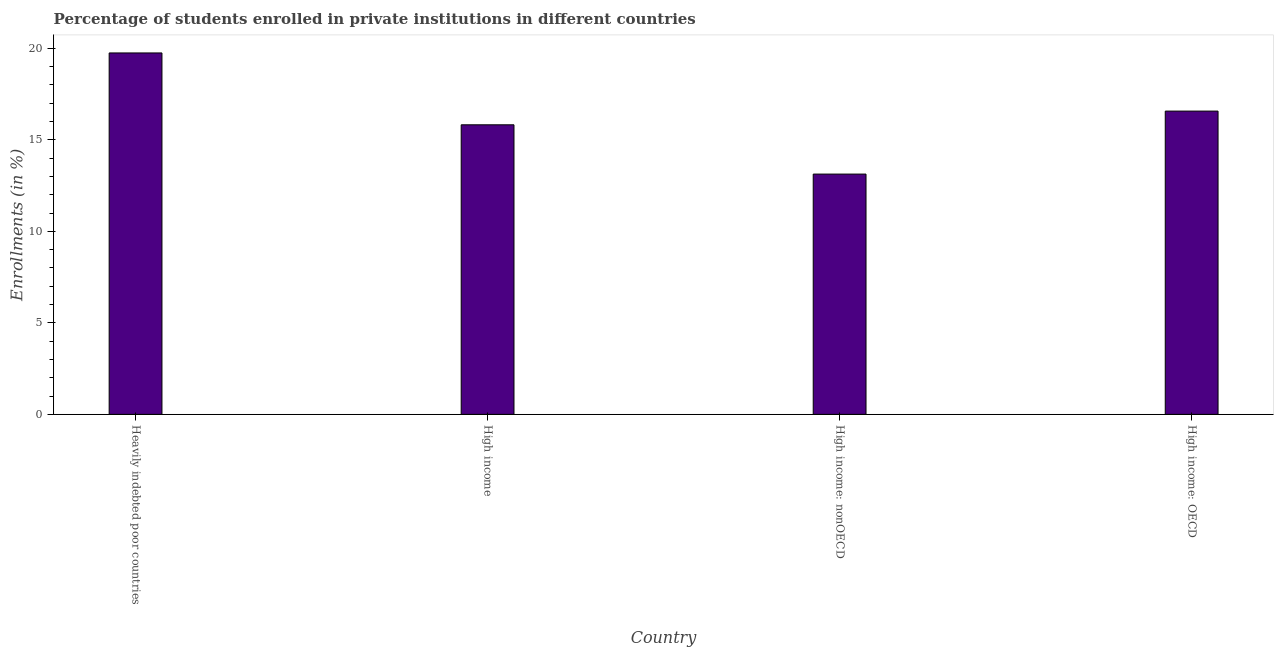Does the graph contain any zero values?
Your response must be concise. No. What is the title of the graph?
Ensure brevity in your answer.  Percentage of students enrolled in private institutions in different countries. What is the label or title of the X-axis?
Your answer should be very brief. Country. What is the label or title of the Y-axis?
Provide a short and direct response. Enrollments (in %). What is the enrollments in private institutions in High income: nonOECD?
Your response must be concise. 13.13. Across all countries, what is the maximum enrollments in private institutions?
Offer a very short reply. 19.75. Across all countries, what is the minimum enrollments in private institutions?
Keep it short and to the point. 13.13. In which country was the enrollments in private institutions maximum?
Your response must be concise. Heavily indebted poor countries. In which country was the enrollments in private institutions minimum?
Make the answer very short. High income: nonOECD. What is the sum of the enrollments in private institutions?
Give a very brief answer. 65.26. What is the difference between the enrollments in private institutions in Heavily indebted poor countries and High income: nonOECD?
Offer a very short reply. 6.62. What is the average enrollments in private institutions per country?
Offer a very short reply. 16.32. What is the median enrollments in private institutions?
Offer a very short reply. 16.2. In how many countries, is the enrollments in private institutions greater than 11 %?
Offer a very short reply. 4. What is the ratio of the enrollments in private institutions in Heavily indebted poor countries to that in High income: OECD?
Give a very brief answer. 1.19. Is the enrollments in private institutions in High income less than that in High income: OECD?
Provide a succinct answer. Yes. What is the difference between the highest and the second highest enrollments in private institutions?
Give a very brief answer. 3.18. What is the difference between the highest and the lowest enrollments in private institutions?
Ensure brevity in your answer.  6.62. In how many countries, is the enrollments in private institutions greater than the average enrollments in private institutions taken over all countries?
Make the answer very short. 2. What is the Enrollments (in %) of Heavily indebted poor countries?
Your answer should be compact. 19.75. What is the Enrollments (in %) of High income?
Your response must be concise. 15.82. What is the Enrollments (in %) in High income: nonOECD?
Give a very brief answer. 13.13. What is the Enrollments (in %) in High income: OECD?
Give a very brief answer. 16.57. What is the difference between the Enrollments (in %) in Heavily indebted poor countries and High income?
Provide a short and direct response. 3.93. What is the difference between the Enrollments (in %) in Heavily indebted poor countries and High income: nonOECD?
Offer a terse response. 6.62. What is the difference between the Enrollments (in %) in Heavily indebted poor countries and High income: OECD?
Your response must be concise. 3.18. What is the difference between the Enrollments (in %) in High income and High income: nonOECD?
Provide a succinct answer. 2.69. What is the difference between the Enrollments (in %) in High income and High income: OECD?
Give a very brief answer. -0.75. What is the difference between the Enrollments (in %) in High income: nonOECD and High income: OECD?
Keep it short and to the point. -3.44. What is the ratio of the Enrollments (in %) in Heavily indebted poor countries to that in High income?
Keep it short and to the point. 1.25. What is the ratio of the Enrollments (in %) in Heavily indebted poor countries to that in High income: nonOECD?
Provide a short and direct response. 1.5. What is the ratio of the Enrollments (in %) in Heavily indebted poor countries to that in High income: OECD?
Provide a short and direct response. 1.19. What is the ratio of the Enrollments (in %) in High income to that in High income: nonOECD?
Provide a short and direct response. 1.21. What is the ratio of the Enrollments (in %) in High income to that in High income: OECD?
Ensure brevity in your answer.  0.95. What is the ratio of the Enrollments (in %) in High income: nonOECD to that in High income: OECD?
Your answer should be compact. 0.79. 